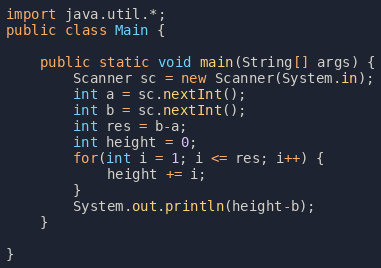<code> <loc_0><loc_0><loc_500><loc_500><_Java_>import java.util.*;
public class Main {

	public static void main(String[] args) {
		Scanner sc = new Scanner(System.in);
		int a = sc.nextInt();
		int b = sc.nextInt();
		int res = b-a;
		int height = 0;
		for(int i = 1; i <= res; i++) {
			height += i;
		}
		System.out.println(height-b);
	}

}</code> 